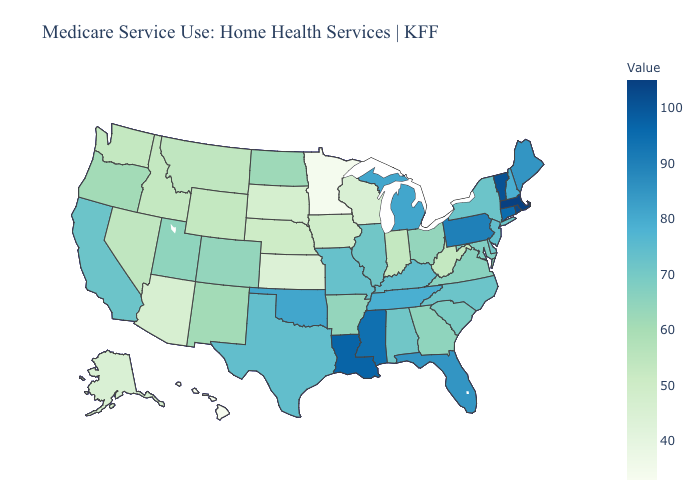Does West Virginia have the lowest value in the South?
Quick response, please. Yes. Does Alabama have the lowest value in the South?
Be succinct. No. Does the map have missing data?
Answer briefly. No. Does the map have missing data?
Answer briefly. No. Among the states that border North Carolina , does South Carolina have the highest value?
Be succinct. No. Among the states that border Indiana , which have the lowest value?
Give a very brief answer. Ohio. Does South Dakota have a higher value than Ohio?
Give a very brief answer. No. Among the states that border Rhode Island , which have the lowest value?
Keep it brief. Connecticut. Does Massachusetts have the highest value in the USA?
Quick response, please. Yes. 